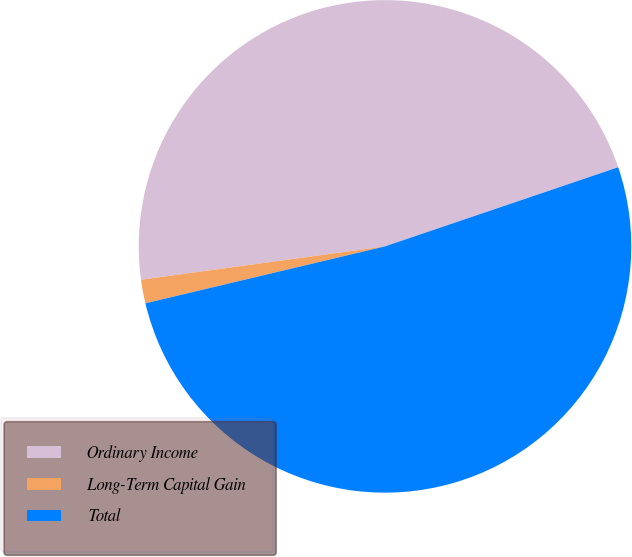Convert chart. <chart><loc_0><loc_0><loc_500><loc_500><pie_chart><fcel>Ordinary Income<fcel>Long-Term Capital Gain<fcel>Total<nl><fcel>46.95%<fcel>1.55%<fcel>51.49%<nl></chart> 